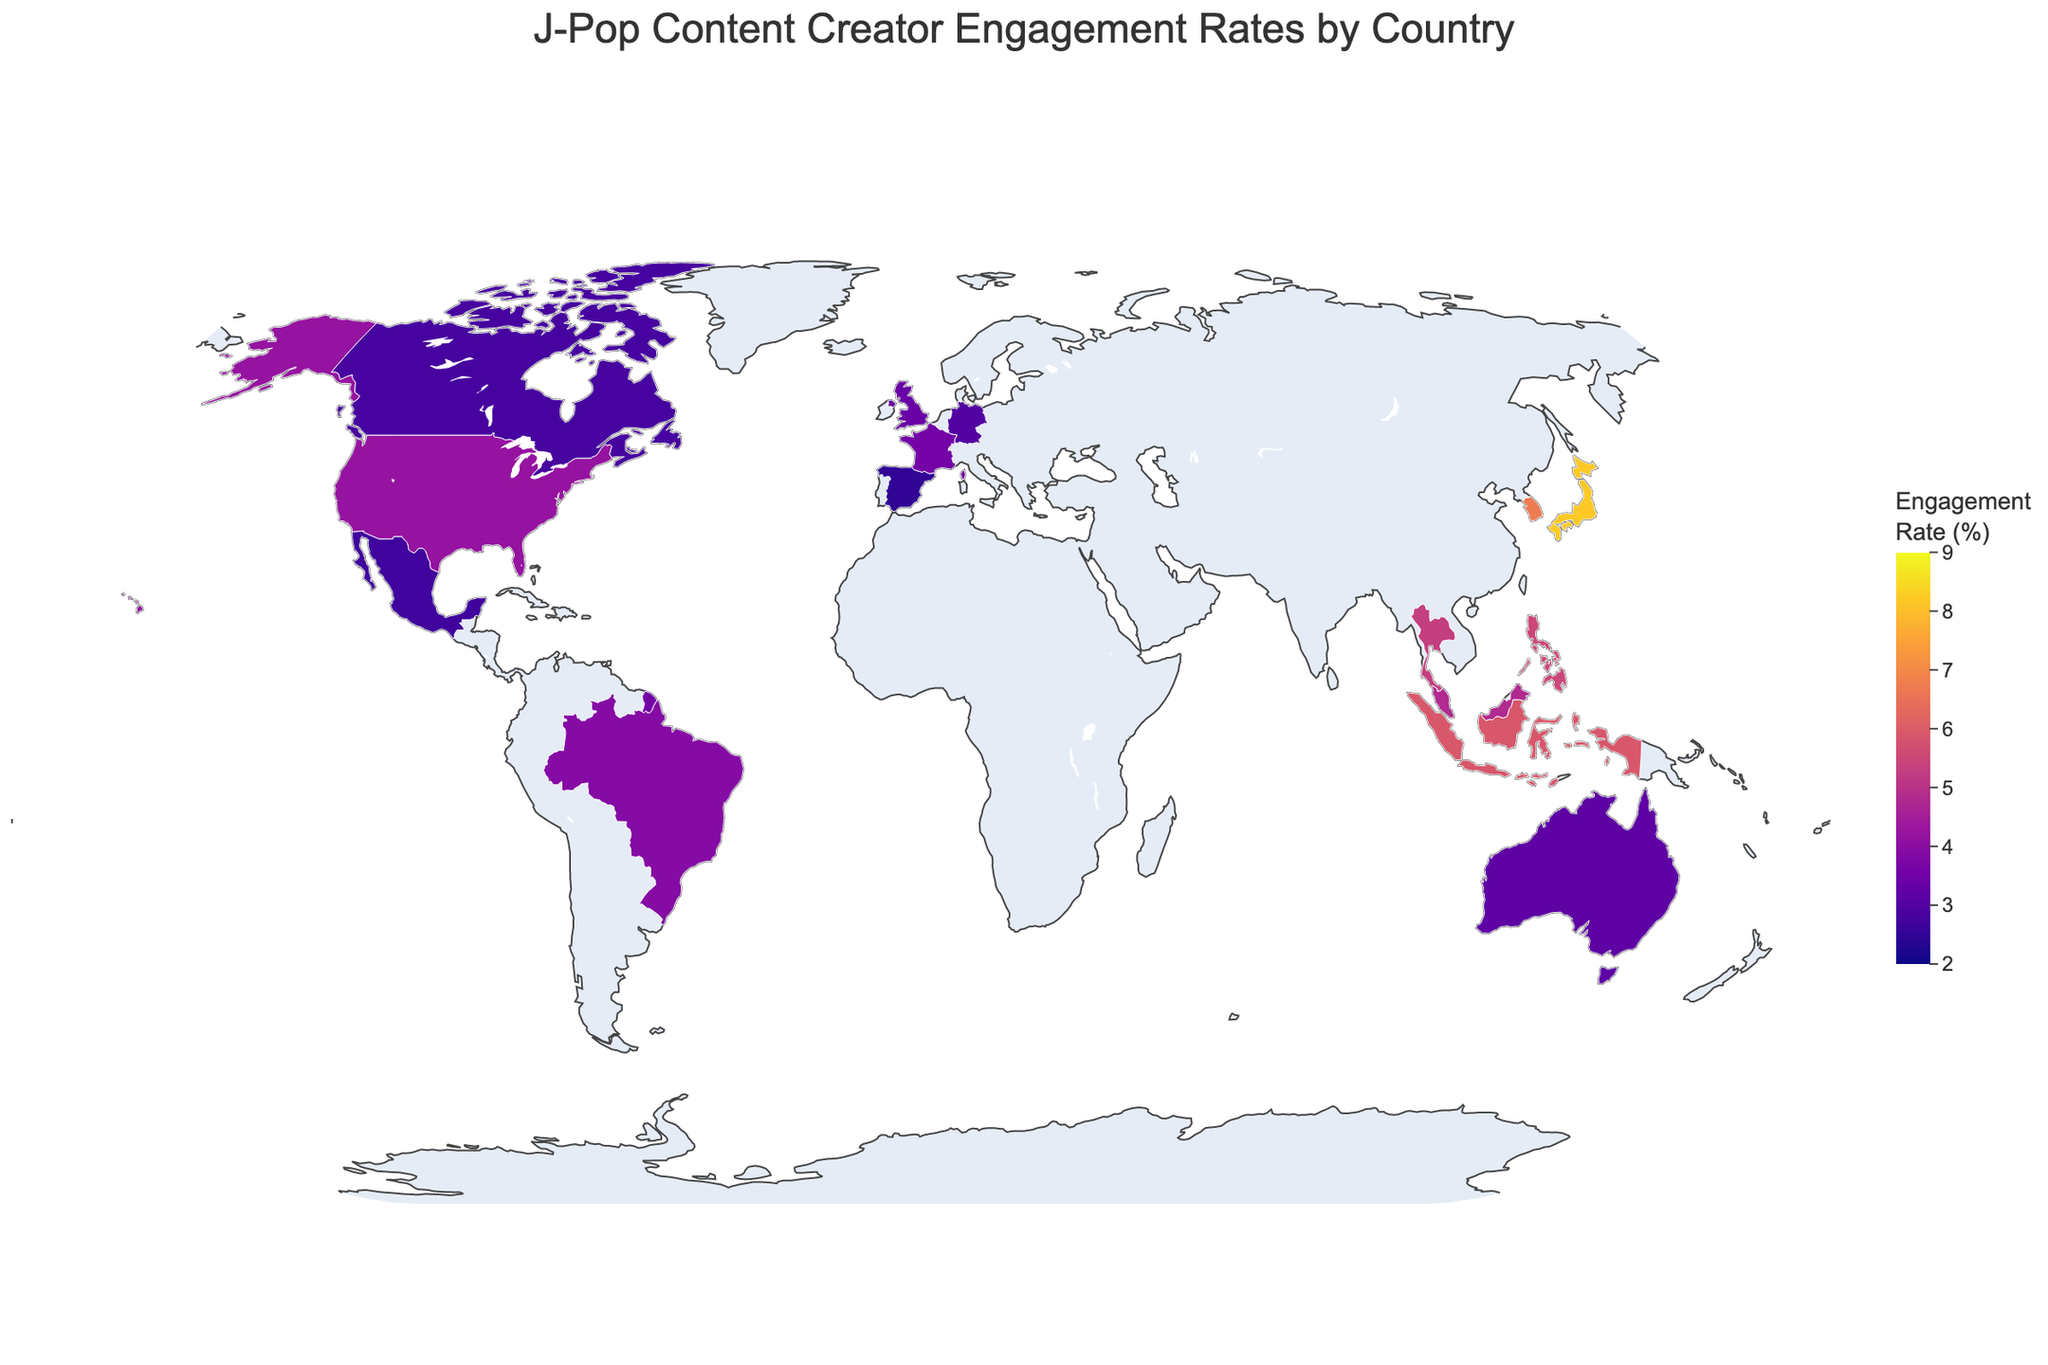What is the title of the figure? The title is usually larger and centered at the top of the figure. The visual information here shows that the title is "J-Pop Content Creator Engagement Rates by Country."
Answer: J-Pop Content Creator Engagement Rates by Country Which country has the highest engagement rate for J-Pop content? Look at the color gradient and hover information. The country with the darkest color indicating the highest engagement rate is Japan at 8.2%.
Answer: Japan How many countries have an engagement rate of 4.0% or higher? Identify the countries that are shaded darker (closer to the high end of the scale). Count the countries within the higher range, including Japan, South Korea, Indonesia, Philippines, Thailand, Malaysia, and the United States.
Answer: 7 What is the average engagement rate among all the countries shown in the figure? To find the average, sum the engagement rates and divide by the number of countries: (8.2 + 6.7 + 5.9 + 5.5 + 5.3 + 4.8 + 4.2 + 3.9 + 3.6 + 3.4 + 3.2 + 3.0 + 2.8 + 2.7 + 2.5) / 15 = 64.7 / 15 ≈ 4.31%.
Answer: 4.31% Which two countries have the closest engagement rates? Compare the engagement rates of each country pair: The United States (4.2%) and Brazil (3.9%) have a close difference of 0.3%.
Answer: United States and Brazil Are there more countries with engagement rates above or below 4%? Count the countries with engagement rates above 4% and those below 4%. There are 7 countries above 4% and 8 countries below 4%.
Answer: Below 4% Is there a noticeable trend in engagement rates between Asian and non-Asian countries? Look for patterns in the regional clusters. Asian countries like Japan, South Korea, Indonesia, Philippines, Thailand, and Malaysia generally show higher engagement rates compared to non-Asian countries like Germany, Canada, and Spain.
Answer: Yes, Asian countries show higher engagement rates Which country in Europe has the highest engagement rate for J-Pop content? Identify European countries on the map and compare their engagement rates. France has the highest engagement rate among European countries at 3.6%.
Answer: France 